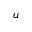Convert formula to latex. <formula><loc_0><loc_0><loc_500><loc_500>u</formula> 